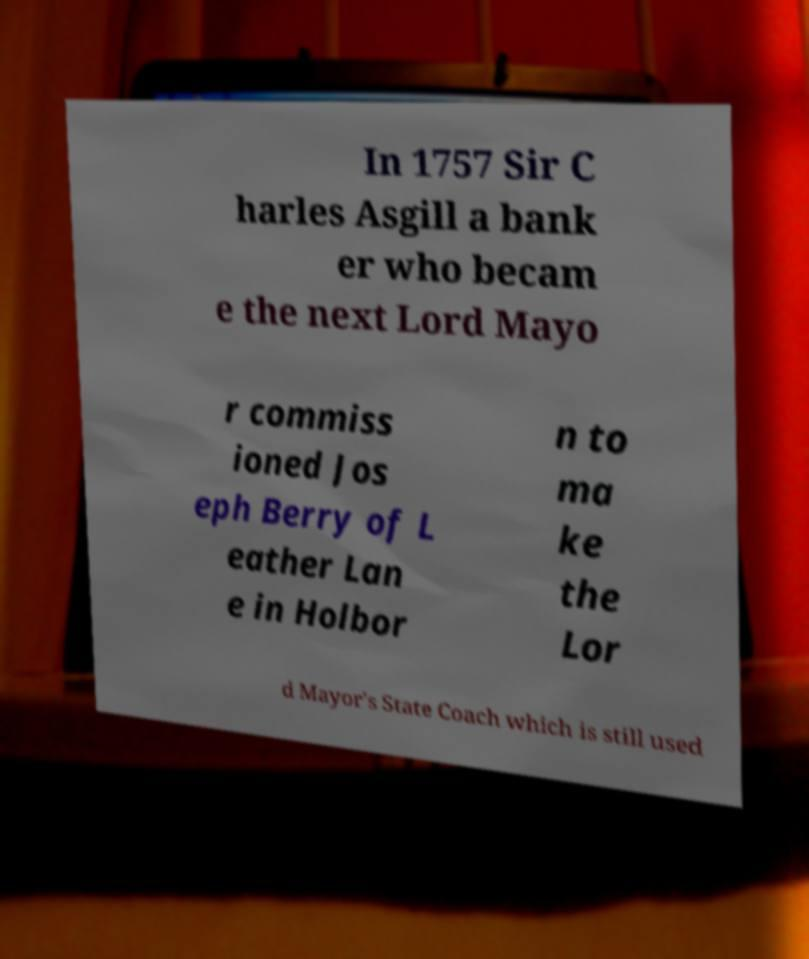For documentation purposes, I need the text within this image transcribed. Could you provide that? In 1757 Sir C harles Asgill a bank er who becam e the next Lord Mayo r commiss ioned Jos eph Berry of L eather Lan e in Holbor n to ma ke the Lor d Mayor's State Coach which is still used 